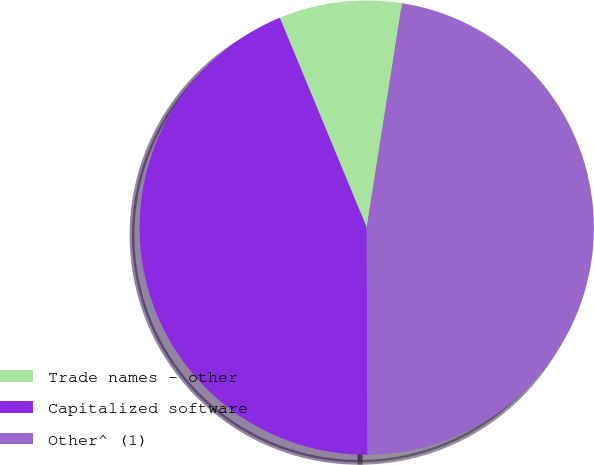Convert chart to OTSL. <chart><loc_0><loc_0><loc_500><loc_500><pie_chart><fcel>Trade names - other<fcel>Capitalized software<fcel>Other^ (1)<nl><fcel>8.74%<fcel>43.81%<fcel>47.45%<nl></chart> 